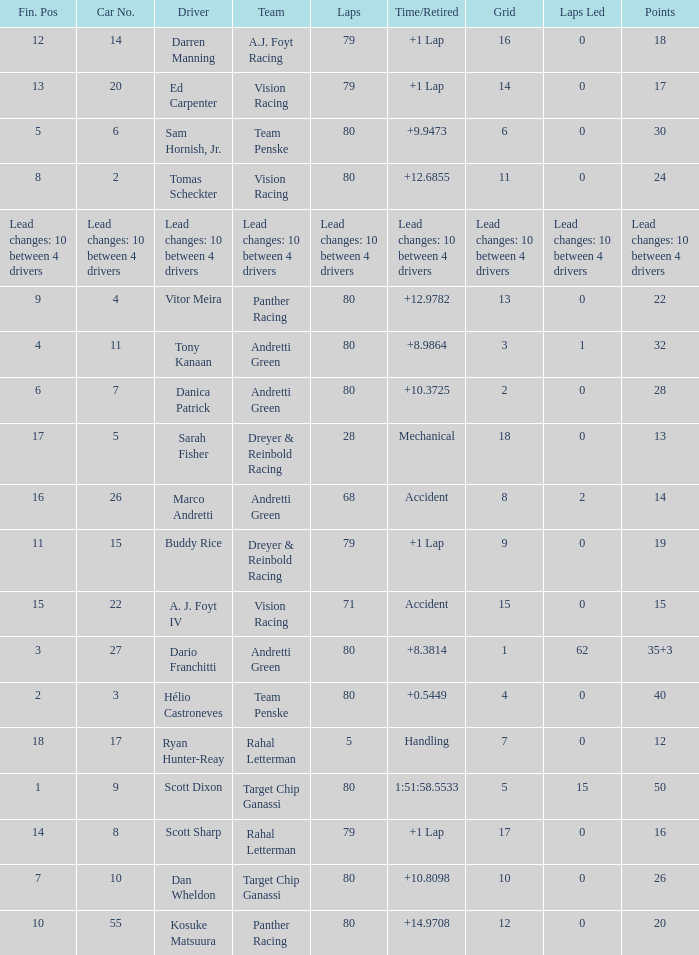Which team possesses 26 points? Target Chip Ganassi. 